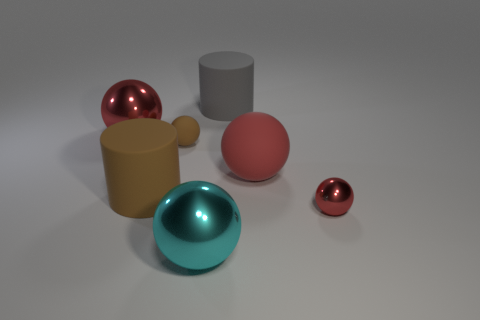The large gray object that is made of the same material as the brown cylinder is what shape?
Your answer should be very brief. Cylinder. Is the number of gray rubber cylinders to the left of the big red matte ball less than the number of big red objects?
Your answer should be compact. Yes. Does the big red matte thing have the same shape as the large cyan object?
Provide a succinct answer. Yes. How many metallic things are either big balls or red objects?
Offer a terse response. 3. Are there any brown metallic cylinders that have the same size as the red matte sphere?
Offer a terse response. No. There is a large object that is the same color as the big rubber ball; what shape is it?
Provide a succinct answer. Sphere. How many other balls are the same size as the cyan metallic sphere?
Your answer should be very brief. 2. Does the matte sphere on the right side of the cyan shiny ball have the same size as the red metallic thing that is in front of the brown matte ball?
Ensure brevity in your answer.  No. How many things are either small matte things or objects that are to the right of the brown rubber sphere?
Your response must be concise. 5. The tiny rubber sphere has what color?
Give a very brief answer. Brown. 